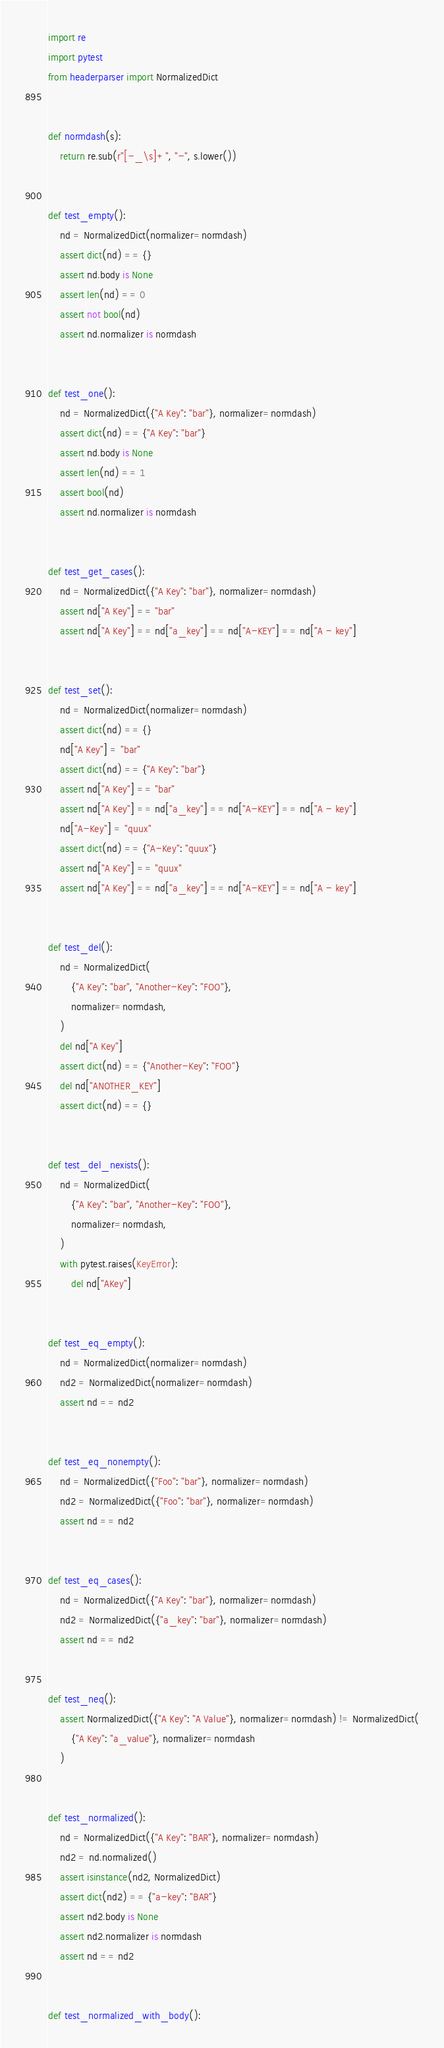Convert code to text. <code><loc_0><loc_0><loc_500><loc_500><_Python_>import re
import pytest
from headerparser import NormalizedDict


def normdash(s):
    return re.sub(r"[-_\s]+", "-", s.lower())


def test_empty():
    nd = NormalizedDict(normalizer=normdash)
    assert dict(nd) == {}
    assert nd.body is None
    assert len(nd) == 0
    assert not bool(nd)
    assert nd.normalizer is normdash


def test_one():
    nd = NormalizedDict({"A Key": "bar"}, normalizer=normdash)
    assert dict(nd) == {"A Key": "bar"}
    assert nd.body is None
    assert len(nd) == 1
    assert bool(nd)
    assert nd.normalizer is normdash


def test_get_cases():
    nd = NormalizedDict({"A Key": "bar"}, normalizer=normdash)
    assert nd["A Key"] == "bar"
    assert nd["A Key"] == nd["a_key"] == nd["A-KEY"] == nd["A - key"]


def test_set():
    nd = NormalizedDict(normalizer=normdash)
    assert dict(nd) == {}
    nd["A Key"] = "bar"
    assert dict(nd) == {"A Key": "bar"}
    assert nd["A Key"] == "bar"
    assert nd["A Key"] == nd["a_key"] == nd["A-KEY"] == nd["A - key"]
    nd["A-Key"] = "quux"
    assert dict(nd) == {"A-Key": "quux"}
    assert nd["A Key"] == "quux"
    assert nd["A Key"] == nd["a_key"] == nd["A-KEY"] == nd["A - key"]


def test_del():
    nd = NormalizedDict(
        {"A Key": "bar", "Another-Key": "FOO"},
        normalizer=normdash,
    )
    del nd["A Key"]
    assert dict(nd) == {"Another-Key": "FOO"}
    del nd["ANOTHER_KEY"]
    assert dict(nd) == {}


def test_del_nexists():
    nd = NormalizedDict(
        {"A Key": "bar", "Another-Key": "FOO"},
        normalizer=normdash,
    )
    with pytest.raises(KeyError):
        del nd["AKey"]


def test_eq_empty():
    nd = NormalizedDict(normalizer=normdash)
    nd2 = NormalizedDict(normalizer=normdash)
    assert nd == nd2


def test_eq_nonempty():
    nd = NormalizedDict({"Foo": "bar"}, normalizer=normdash)
    nd2 = NormalizedDict({"Foo": "bar"}, normalizer=normdash)
    assert nd == nd2


def test_eq_cases():
    nd = NormalizedDict({"A Key": "bar"}, normalizer=normdash)
    nd2 = NormalizedDict({"a_key": "bar"}, normalizer=normdash)
    assert nd == nd2


def test_neq():
    assert NormalizedDict({"A Key": "A Value"}, normalizer=normdash) != NormalizedDict(
        {"A Key": "a_value"}, normalizer=normdash
    )


def test_normalized():
    nd = NormalizedDict({"A Key": "BAR"}, normalizer=normdash)
    nd2 = nd.normalized()
    assert isinstance(nd2, NormalizedDict)
    assert dict(nd2) == {"a-key": "BAR"}
    assert nd2.body is None
    assert nd2.normalizer is normdash
    assert nd == nd2


def test_normalized_with_body():</code> 